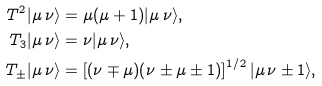Convert formula to latex. <formula><loc_0><loc_0><loc_500><loc_500>T ^ { 2 } | \mu \, \nu \rangle & = \mu ( \mu + 1 ) | \mu \, \nu \rangle , \\ T _ { 3 } | \mu \, \nu \rangle & = \nu | \mu \, \nu \rangle , \\ T _ { \pm } | \mu \, \nu \rangle & = \left [ ( \nu \mp \mu ) ( \nu \pm \mu \pm 1 ) \right ] ^ { 1 / 2 } | \mu \, \nu \pm 1 \rangle ,</formula> 